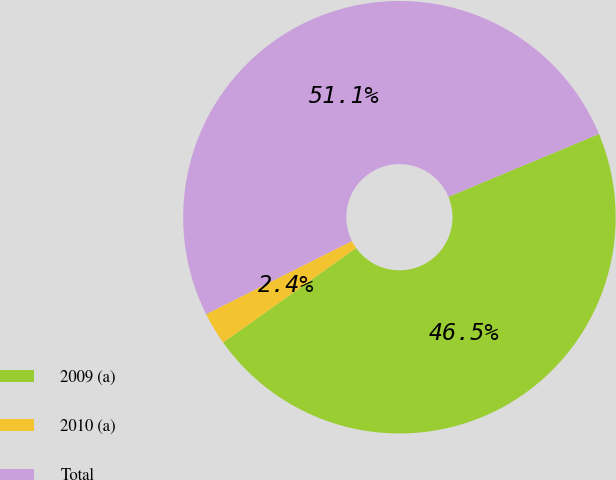Convert chart. <chart><loc_0><loc_0><loc_500><loc_500><pie_chart><fcel>2009 (a)<fcel>2010 (a)<fcel>Total<nl><fcel>46.45%<fcel>2.44%<fcel>51.1%<nl></chart> 